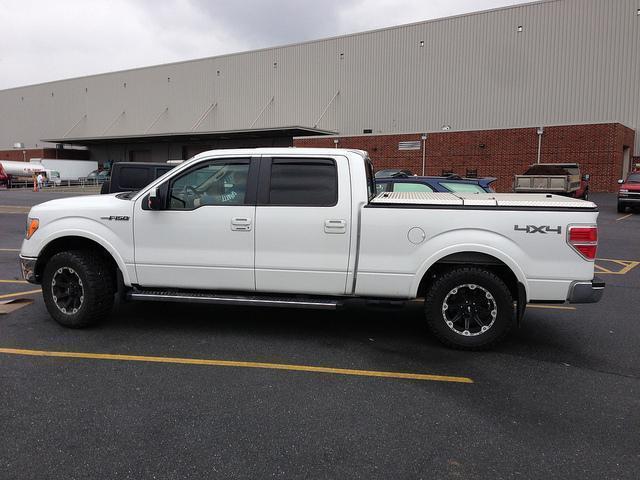How many tents are there?
Give a very brief answer. 0. How many doors does the car have?
Give a very brief answer. 4. How many trucks are there?
Give a very brief answer. 2. 